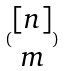<formula> <loc_0><loc_0><loc_500><loc_500>( \begin{matrix} [ n ] \\ m \end{matrix} )</formula> 